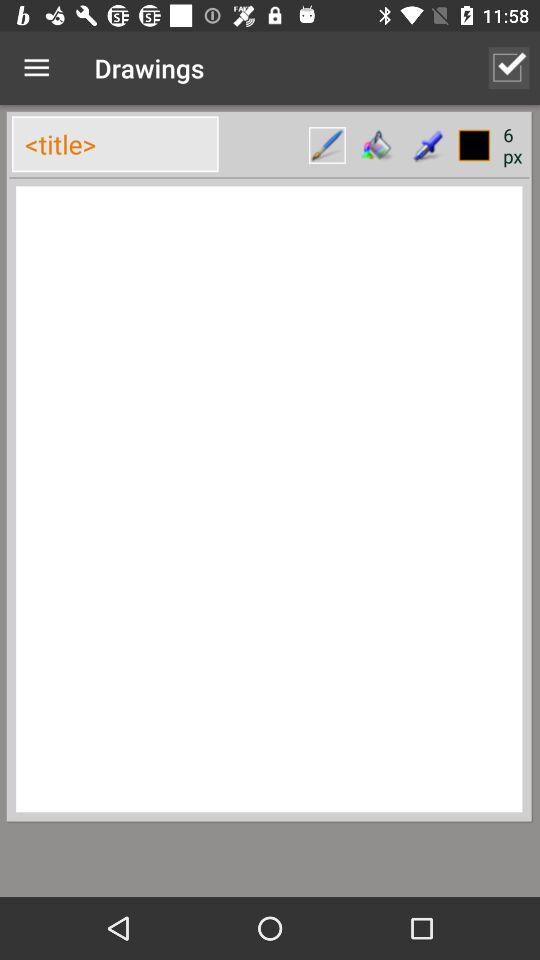What is the status of "Drawings"? The status of "Drawings" is "on". 